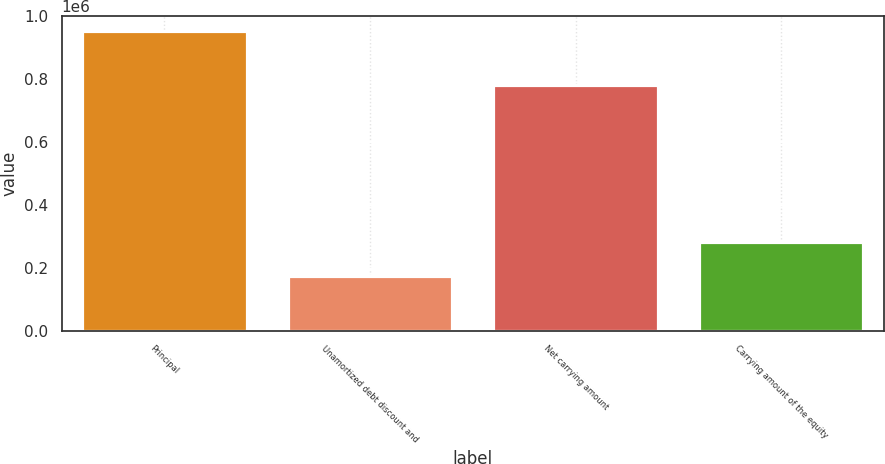<chart> <loc_0><loc_0><loc_500><loc_500><bar_chart><fcel>Principal<fcel>Unamortized debt discount and<fcel>Net carrying amount<fcel>Carrying amount of the equity<nl><fcel>954000<fcel>173181<fcel>780819<fcel>283283<nl></chart> 